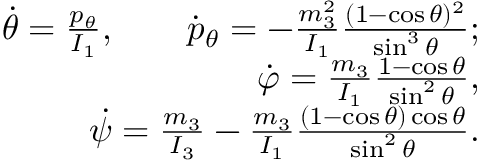Convert formula to latex. <formula><loc_0><loc_0><loc_500><loc_500>\begin{array} { r } { \dot { \theta } = \frac { p _ { \theta } } { I _ { 1 } } , \quad \dot { p } _ { \theta } = - \frac { m _ { 3 } ^ { 2 } } { I _ { 1 } } \frac { ( 1 - \cos \theta ) ^ { 2 } } { \sin ^ { 3 } \theta } ; } \\ { \dot { \varphi } = \frac { m _ { 3 } } { I _ { 1 } } \frac { 1 - \cos \theta } { \sin ^ { 2 } \theta } , } \\ { \dot { \psi } = \frac { m _ { 3 } } { I _ { 3 } } - \frac { m _ { 3 } } { I _ { 1 } } \frac { ( 1 - \cos \theta ) \cos \theta } { \sin ^ { 2 } \theta } . } \end{array}</formula> 